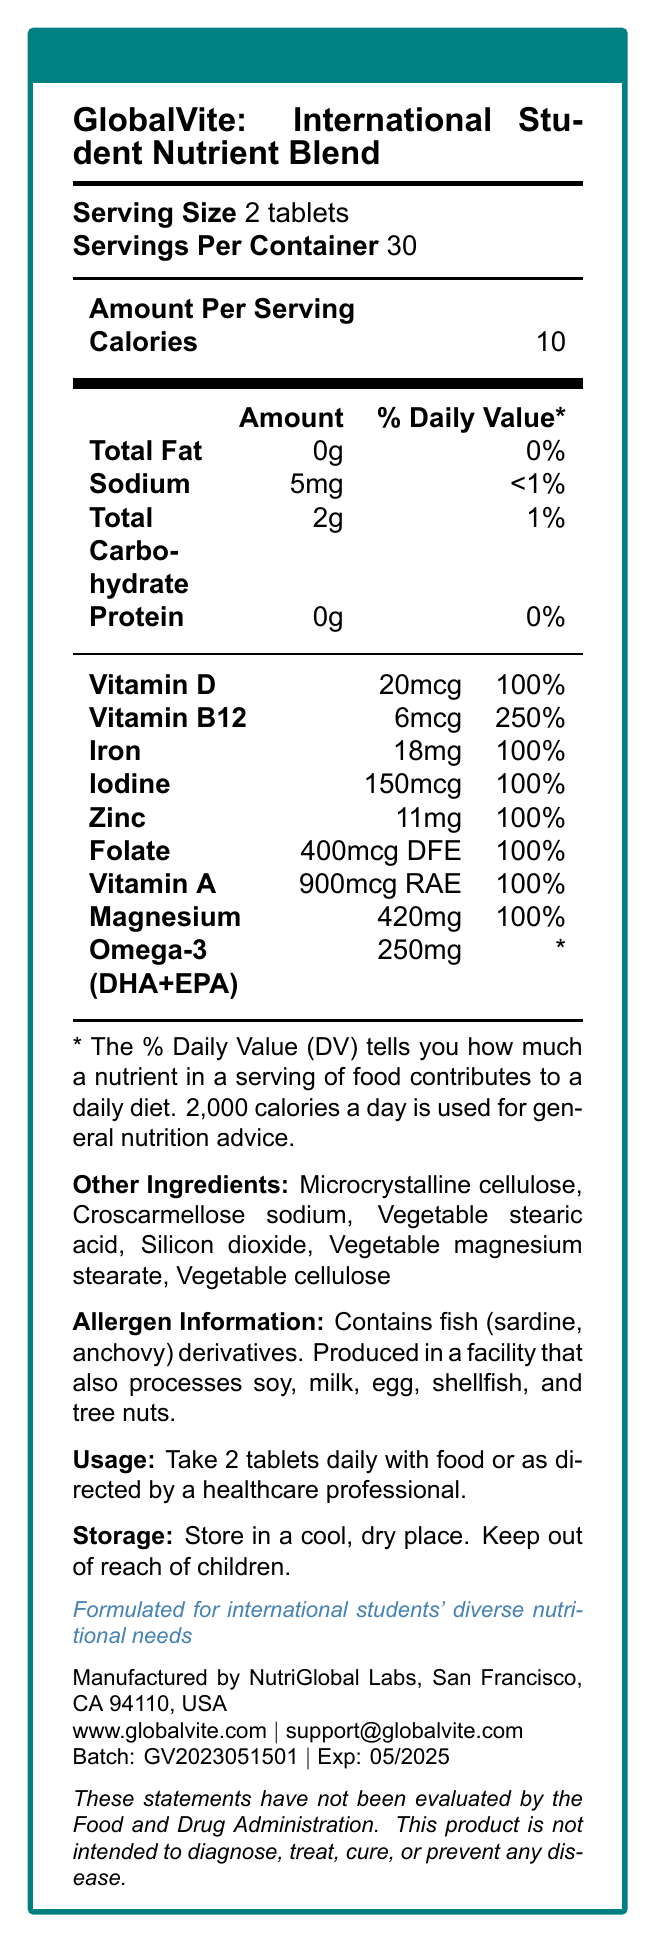What is the serving size of GlobalVite: International Student Nutrient Blend? The serving size is mentioned as "2 tablets" under the "Serving Size" section.
Answer: 2 tablets How many servings per container are there? The document specifies "Servings Per Container: 30".
Answer: 30 How many calories are in each serving of the vitamin blend? The "Amount Per Serving" section lists "Calories: 10".
Answer: 10 What is the daily value percentage of Vitamin D provided by this product? The "Vitamins and Minerals" section shows "Vitamin D: 20mcg, 100%".
Answer: 100% What are the primary ingredients other than the main vitamins and minerals? These are listed under "Other Ingredients".
Answer: Microcrystalline cellulose, Croscarmellose sodium, Vegetable stearic acid, Silicon dioxide, Vegetable magnesium stearate, Vegetable cellulose Which nutrient has the highest daily value percentage? Vitamin B12 has a daily value percentage of 250%, which is the highest among the listed nutrients.
Answer: Vitamin B12 Does this product contain any allergens? The "Allergen Information" section indicates that it contains fish derivatives.
Answer: Yes. Fish (sardine, anchovy) derivatives. How should this product be stored? The “Storage Instructions” section advises to store it in a cool, dry place and keep it out of children's reach.
Answer: In a cool, dry place. Keep out of reach of children. (Which of the following nutrients does the product contain? A. Vitamin C B. Vitamin B12 C. Calcium D. Fiber The document lists Vitamin B12. It does not mention Vitamin C, Calcium, or Fiber.)
Answer: B What is the potassium content in this product? The document doesn't provide information on potassium content.
Answer: Cannot be determined Who manufactures GlobalVite: International Student Nutrient Blend? The manufacturer information is provided at the bottom of the document.
Answer: NutriGlobal Labs, San Francisco, CA 94110, USA (True/False: The product is intended to diagnose, treat, cure, or prevent diseases. The disclaimer states that the product is not intended to diagnose, treat, cure, or prevent any disease.)
Answer: False (List 3 features of GlobalVite: International Student Nutrient Blend. These features are listed under "Product Features".)
Answer: Formulated for international students' diverse nutritional needs, Supports cognitive function and energy metabolism, Aids in maintaining healthy immune system What is the batch number and expiration date of the product? The batch number and expiration date are provided at the bottom of the document.)
Answer: Batch: GV2023051501, Exp: 05/2025 Which nutrient has a daily value marked as "*" instead of a percentage? The table of vitamins and minerals shows "Omega-3 (DHA+EPA) 250mg *".
Answer: Omega-3 (DHA+EPA) (Summarize the main purpose and key elements of the document. The document provides a detailed breakdown of the nutrient content and additional product information for GlobalVite, which is designed to address the nutritional deficiencies commonly faced by international students. It highlights serving size, key vitamins and minerals, allergens, usage instructions, and the manufacturer details.
Answer: The document provides comprehensive nutritional information about the GlobalVite: International Student Nutrient Blend. It includes serving size, servings per container, calories, detailed amounts and daily values of various vitamins and minerals, allergen information, usage and storage instructions, product features, manufacturer, and contact information. The product is tailored to meet the diverse nutritional needs of international students and aims to support cognitive function, energy metabolism, and overall health.) 